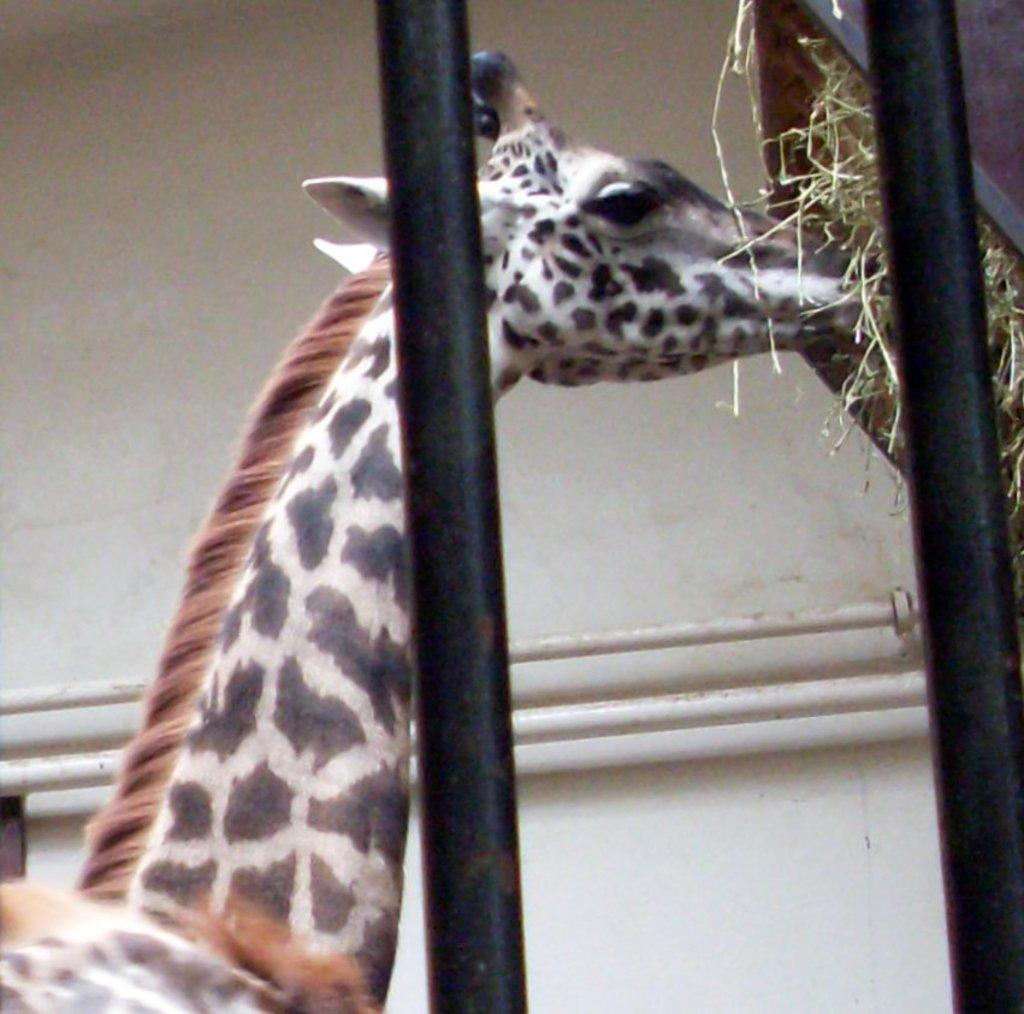What animal is present in the image? There is a giraffe in the image. What is the giraffe doing in the image? The giraffe is eating grass in the image. How is the grass being contained in the image? The grass is in a basket in the image. What is the setting of the image? The giraffe is in a cage in the image, and there is a white wall and white color pipes in the background. What type of doll is sitting with the giraffe's friends in the image? There is no doll or friends of the giraffe present in the image. What kind of stamp can be seen on the white wall in the background? There is no stamp visible on the white wall in the background of the image. 